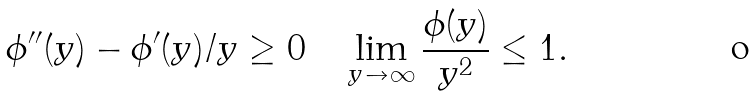Convert formula to latex. <formula><loc_0><loc_0><loc_500><loc_500>\phi ^ { \prime \prime } ( y ) - \phi ^ { \prime } ( y ) / y \geq 0 \quad \lim _ { y \to \infty } \frac { \phi ( y ) } { y ^ { 2 } } \leq 1 .</formula> 